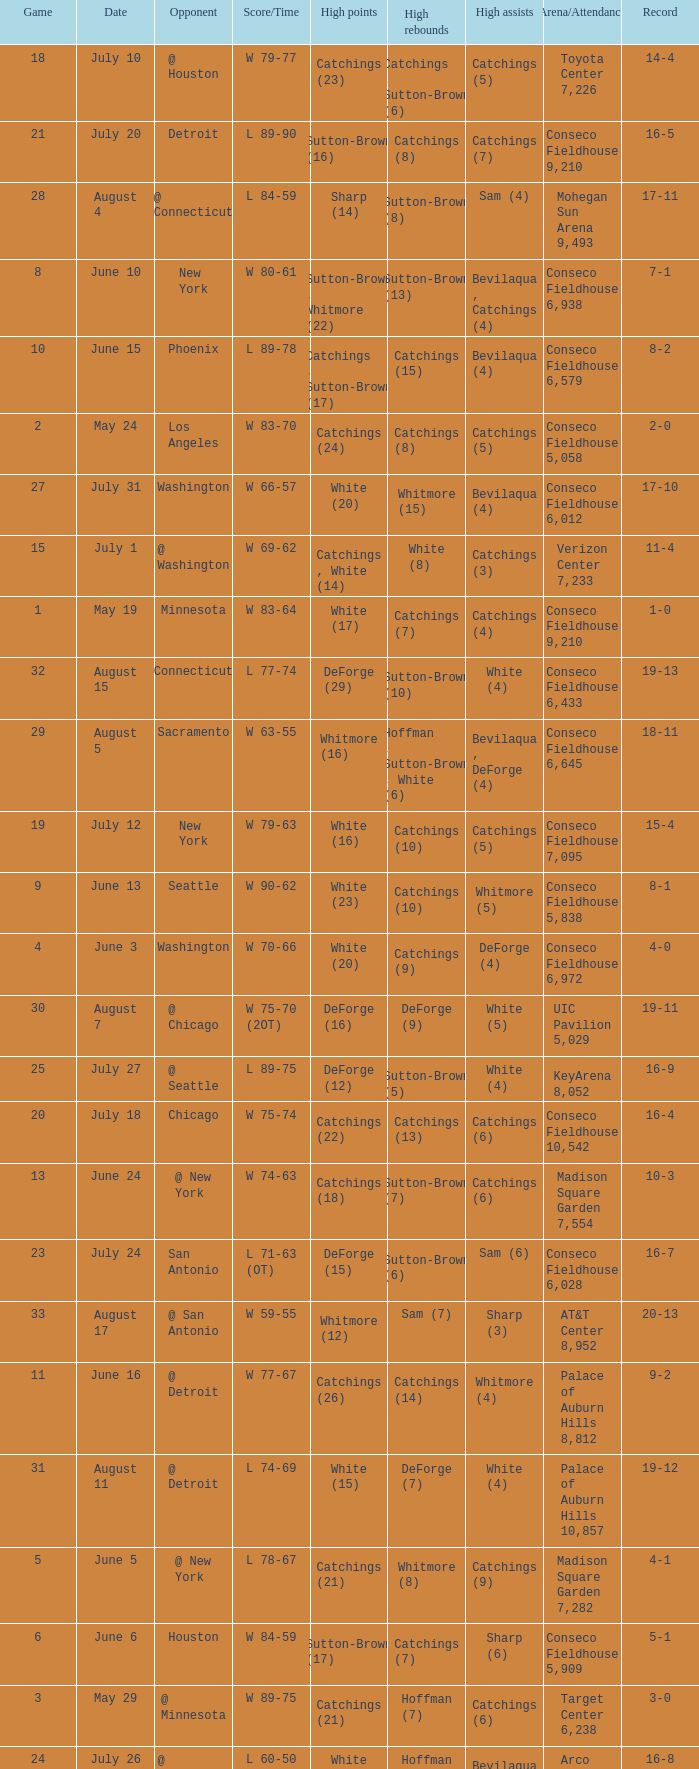Name the date where score time is w 74-63 June 24. 